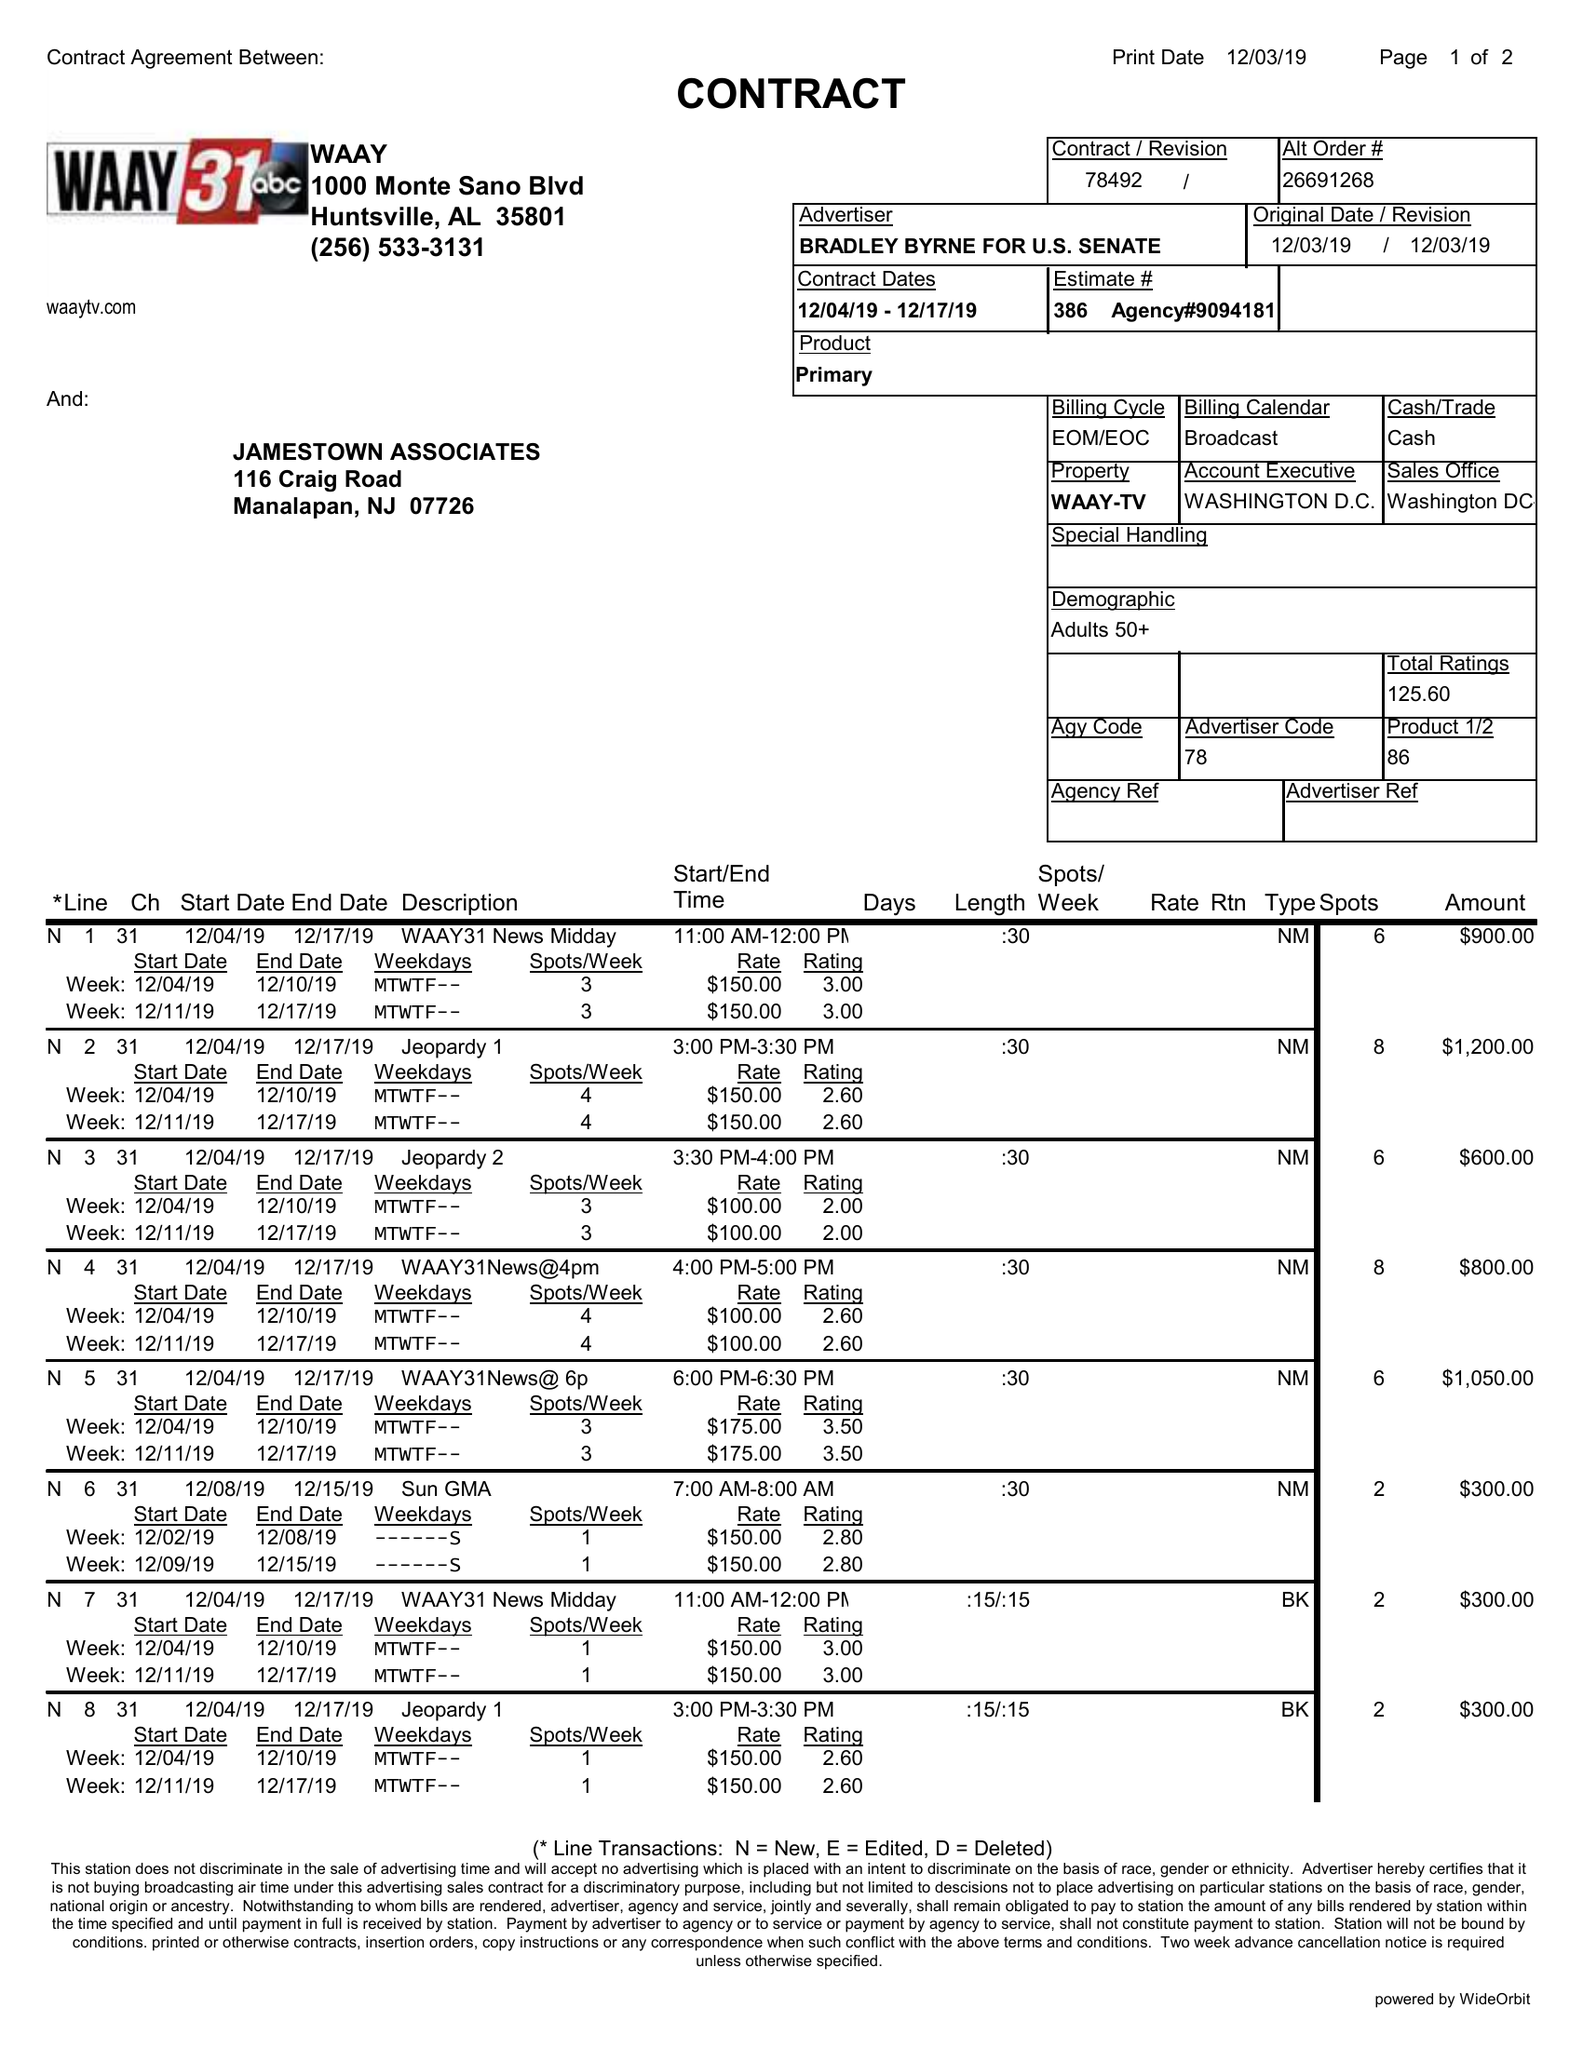What is the value for the contract_num?
Answer the question using a single word or phrase. 78492 